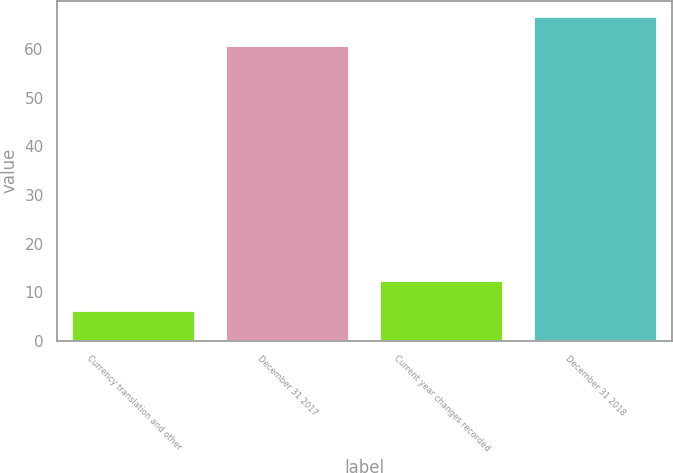Convert chart. <chart><loc_0><loc_0><loc_500><loc_500><bar_chart><fcel>Currency translation and other<fcel>December 31 2017<fcel>Current year changes recorded<fcel>December 31 2018<nl><fcel>6.2<fcel>60.6<fcel>12.2<fcel>66.6<nl></chart> 